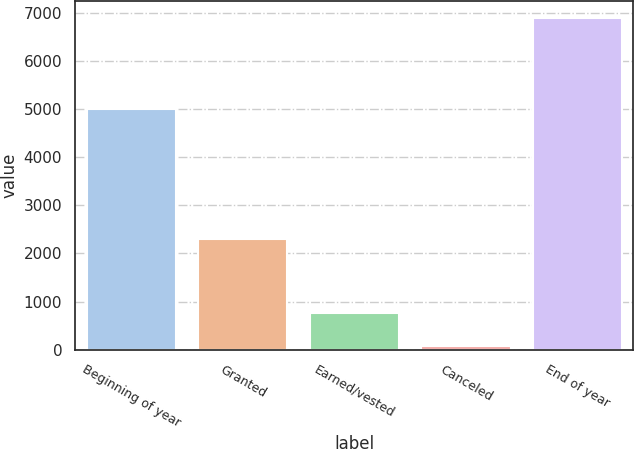<chart> <loc_0><loc_0><loc_500><loc_500><bar_chart><fcel>Beginning of year<fcel>Granted<fcel>Earned/vested<fcel>Canceled<fcel>End of year<nl><fcel>4999<fcel>2295<fcel>767.2<fcel>86<fcel>6898<nl></chart> 